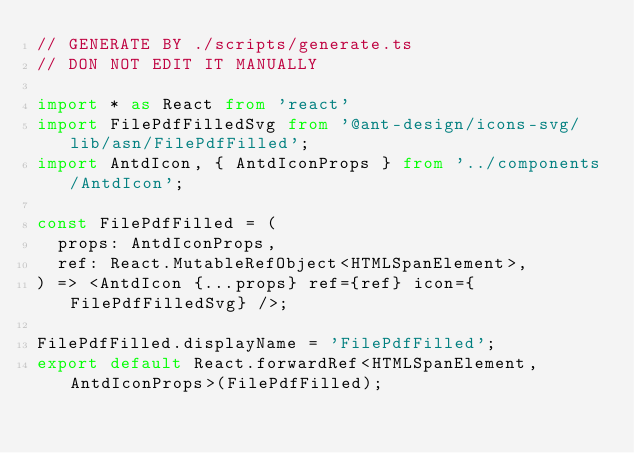<code> <loc_0><loc_0><loc_500><loc_500><_TypeScript_>// GENERATE BY ./scripts/generate.ts
// DON NOT EDIT IT MANUALLY

import * as React from 'react'
import FilePdfFilledSvg from '@ant-design/icons-svg/lib/asn/FilePdfFilled';
import AntdIcon, { AntdIconProps } from '../components/AntdIcon';

const FilePdfFilled = (
  props: AntdIconProps,
  ref: React.MutableRefObject<HTMLSpanElement>,
) => <AntdIcon {...props} ref={ref} icon={FilePdfFilledSvg} />;

FilePdfFilled.displayName = 'FilePdfFilled';
export default React.forwardRef<HTMLSpanElement, AntdIconProps>(FilePdfFilled);</code> 